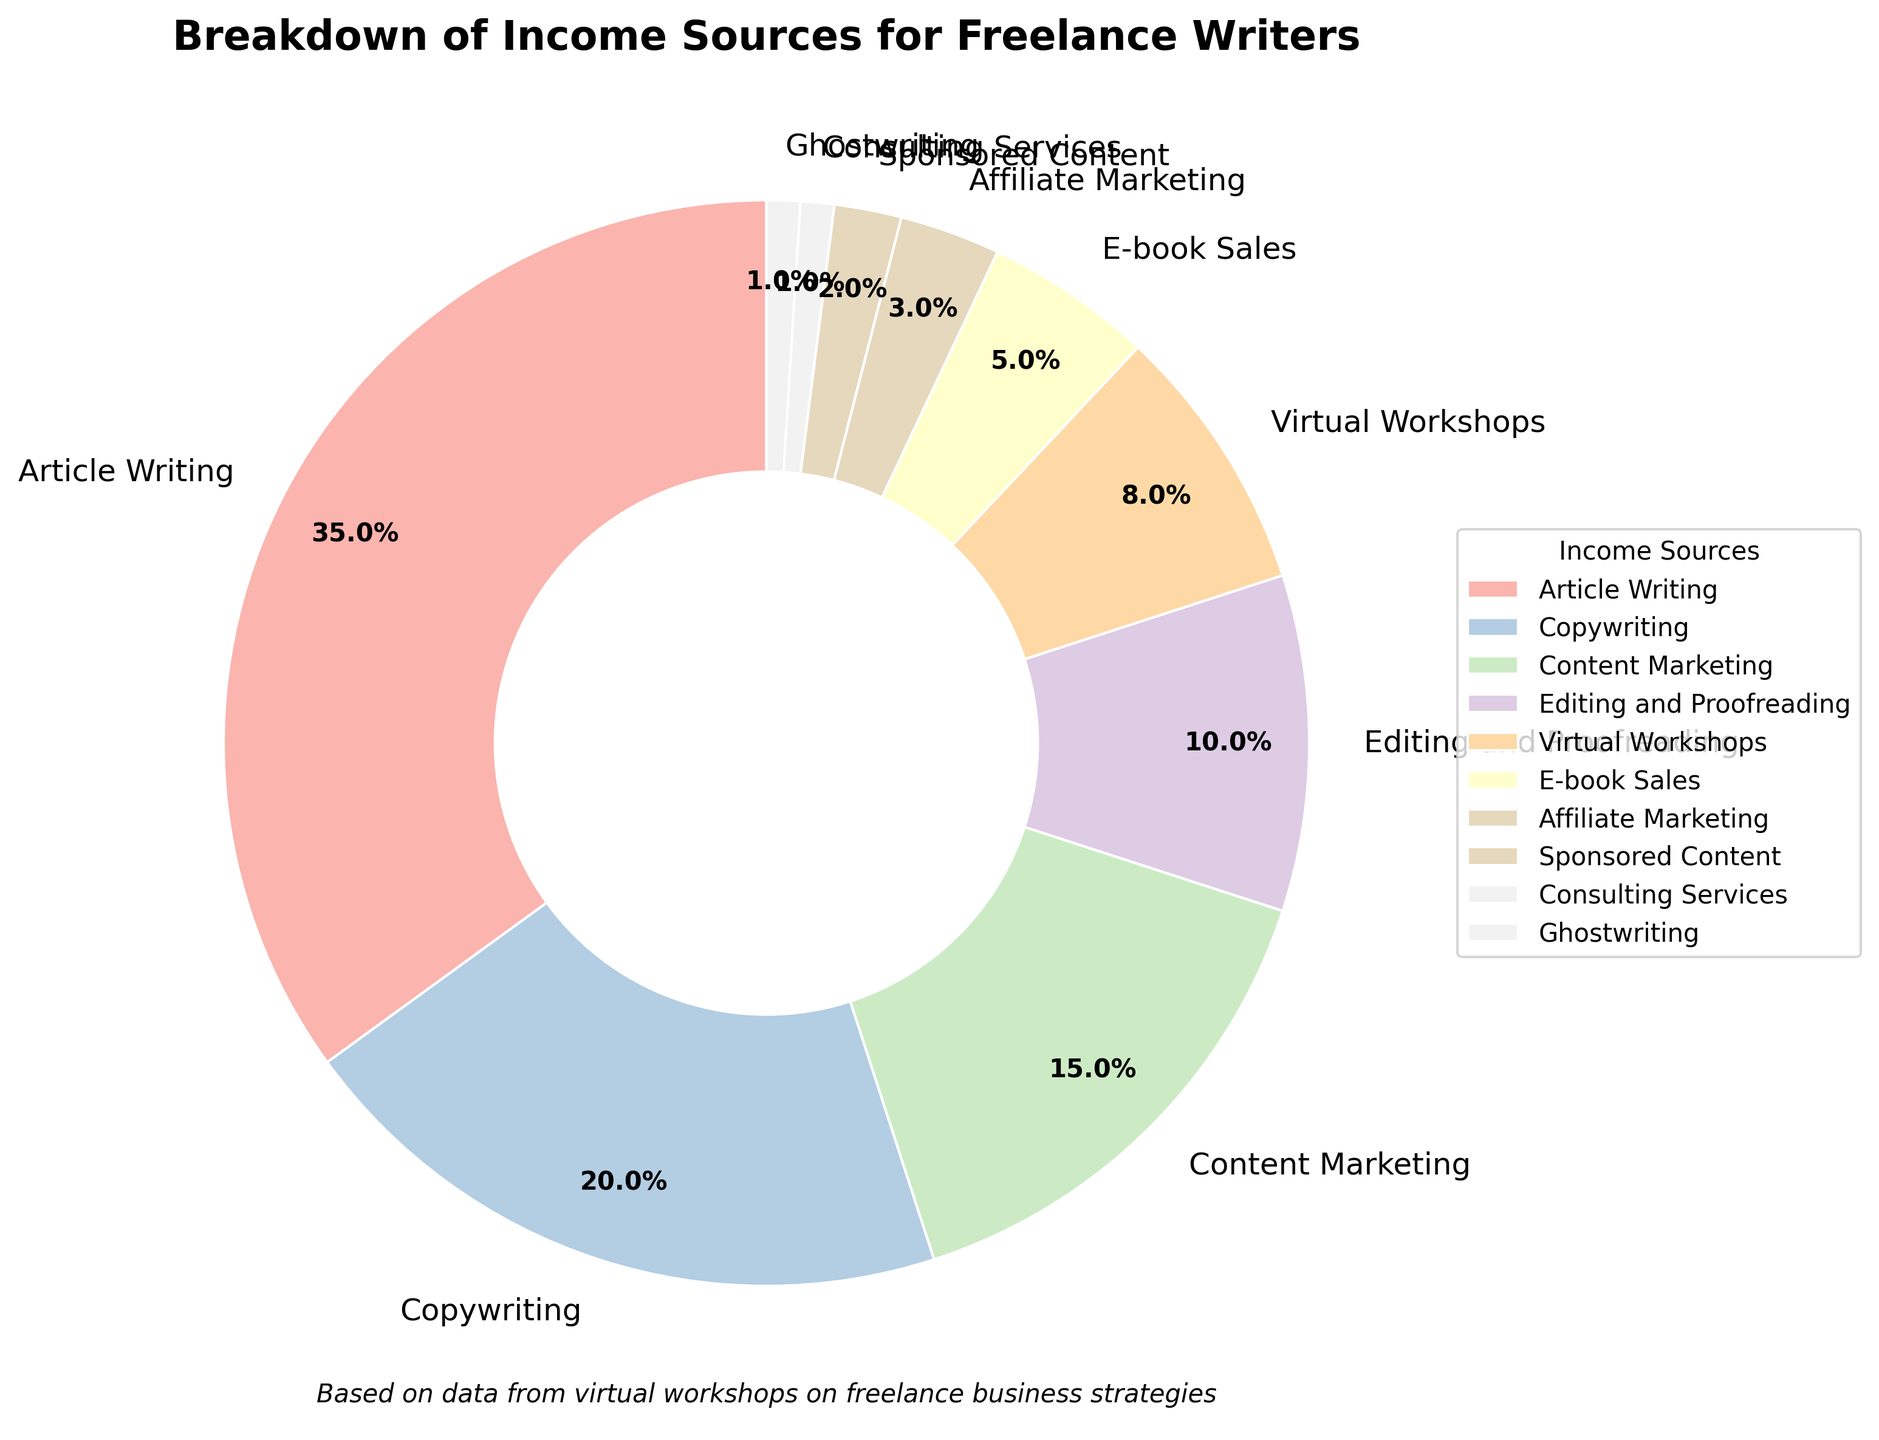Which income source has the highest percentage? By looking at the wedges in the pie chart, identify the one with the largest size. The label next to this wedge will indicate the income source.
Answer: Article Writing What is the combined percentage for Copywriting and Content Marketing? Find the wedges labeled Copywriting and Content Marketing. Add their respective percentages (20% for Copywriting and 15% for Content Marketing).
Answer: 35% How does the percentage of Virtual Workshops compare to that of E-book Sales? Locate the wedges for Virtual Workshops and E-book Sales. Compare their percentages, 8% for Virtual Workshops and 5% for E-book Sales, and note that Virtual Workshops have a higher percentage.
Answer: Virtual Workshops have a higher percentage Which income source has the smallest contribution? Identify the smallest wedge in the pie chart and read the label. The smallest wedge corresponds to Consulting Services and Ghostwriting, each at 1%.
Answer: Consulting Services and Ghostwriting What is the total percentage of income from Editing and Proofreading, Virtual Workshops, and Affiliate Marketing? Find the percentages for Editing and Proofreading (10%), Virtual Workshops (8%), and Affiliate Marketing (3%). Add them together: 10% + 8% + 3%.
Answer: 21% If you were to combine Sponsored Content and Consulting Services, what would their combined percentage be? Identify the percentages for Sponsored Content (2%) and Consulting Services (1%). Add them together: 2% + 1%.
Answer: 3% Is the percentage for Article Writing more than three times that of Editing and Proofreading? Article Writing is 35%, and Editing and Proofreading is 10%. Check if 35 is more than three times 10 (i.e., 30).
Answer: Yes Which income sources are represented by wedges with darker shades? By observing the grayscale shades, determine which wedges are visually darker. The wedges for income sources with smaller percentages generally appear darker.
Answer: Ghostwriting and Consulting Services What is the difference in percentage between Copywriting and Affiliate Marketing? Identify the percentages for Copywriting (20%) and Affiliate Marketing (3%). Subtract the smaller percentage from the larger: 20% - 3%.
Answer: 17% If we combine the percentages of Article Writing, Copywriting, and Content Marketing, what portion of the pie chart do they occupy? Find the percentages for Article Writing (35%), Copywriting (20%), and Content Marketing (15%). Add them together: 35% + 20% + 15%.
Answer: 70% 